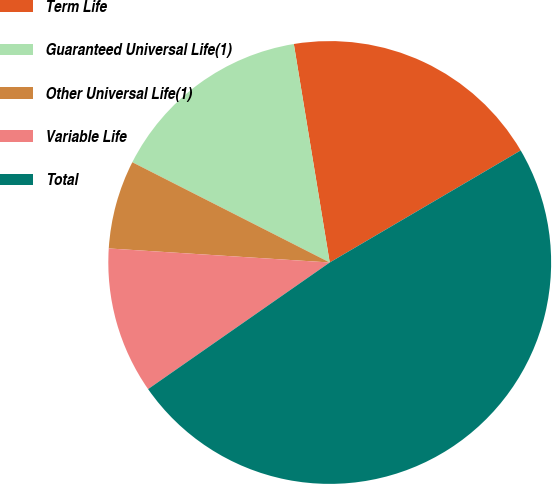Convert chart to OTSL. <chart><loc_0><loc_0><loc_500><loc_500><pie_chart><fcel>Term Life<fcel>Guaranteed Universal Life(1)<fcel>Other Universal Life(1)<fcel>Variable Life<fcel>Total<nl><fcel>19.15%<fcel>14.93%<fcel>6.47%<fcel>10.7%<fcel>48.76%<nl></chart> 